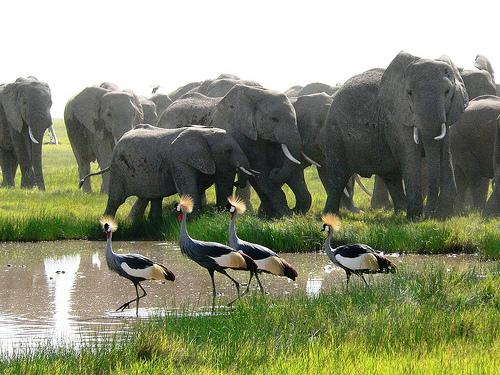What animals are interacting with each other in the image? Elephants and birds are interacting in the image, with birds walking in the water and elephants walking on the grass. Examine the image and determine whether any objects in the image could potentially cause harm or danger. There is no apparent threat or danger in the image, as it depicts a peaceful scene of elephants and birds in a natural environment. Using your understanding of the image's content, predict what might happen next. The elephants might continue to walk and graze on the grass, while the birds may keep walking in the water or take flight at some point, with their interactions remaining peaceful and undisturbed. Ensure the image's quality by describing the clarity and visibility of important elements. The image has good quality, with the objects clearly visible and well-defined, such as the elephants, birds, water, grass, and even finer details like elephant tusks and tails. Infer the possible reasons why elephants and birds are present in the same area. The elephants and birds might be present in the same area because they are both seeking water and food resources, or because they share a harmonious coexistence in their natural habitat. Describe the state of the water and its surroundings in the image. The water has ripples on the surface and a murky brown color, with a light reflection from the sun. It's surrounded by green grass, and the elephants and the birds are walking through or near the water. Analyze the sentiment of the image, and describe any emotions or feelings that the image may evoke. The image evokes a sense of tranquility and peacefulness, as it showcases a serene scene of elephants and birds interacting in a natural environment with water and grass. Count the number of elephants in the image and describe their positions. There are five elephants in the image: one large gray elephant looking forward, a baby elephant near its mother, a smallest elephant walking by water, a standing grey elephant, and another standing grey elephant with different positions. Identify the colors and size of the grass in the image. There is tall yellow and green grass that has a width of 207 and a height of 207. Determine the number of birds in the image, and briefly describe their appearances and actions. There are four birds in the image: a black and white lead bird, a black and white second bird, a black and white right hand bird, and a bird with one leg in water and one in the air. They all are walking in the water. Identify any birds that are standing on one leg. Bird with one leg in the water and one in the air, X:95 Y:206 Width:76 Height:76 Locate the white seagull perched on one of the elephants' backs. Mention how its feathers contrast with the elephant's gray skin. The image information does not include a seagull or any object implying it, so the instruction misleads the user by directing them to find an object that doesn't exist in the image. Describe the sentiment evoked by the image. The image evokes a sense of tranquility and harmony with nature. Search for a pink flamingo standing near the water's edge, and notice its majestic posture. No, it's not mentioned in the image. What is the main subject of the image? A group of elephants on the grass by a body of water. Describe the interaction between the baby elephant and its mother. The baby elephant is walking close to its mother, suggesting a bond between them. List three objects that are present in the image. Birds walking in the water, tall yellow and green grass, reflection from the sun on the water. Could you kindly identify the orange butterfly perched on the tall green grass? Comment on its vibrant color and pattern. The image information does not include any butterfly, so asking the user to find one would lead to confusion as they search for an object that isn't present. Determine the exact position of the stone in the grass by water. X:129, Y:337, Width:38, Height:38 Count the total number of birds walking in the water. Four What is the overall quality of the image? Good Is there any text visible in the image? No Which object is closest to the top-left corner of the image? Ripples on the water Please provide a description of the scene shown in the image. The image depicts a group of elephants walking on grass by a body of water, with birds wading in the water and tall grass surrounding the area. Locate the object described as "elephant tail". X:72, Y:156, Width:38, Height:38 Determine the attributes for the black and white lead bird. X:87, Y:203, Width:93, Height:93 Observe the group of people in the top left corner, having a picnic on the grass. Notice the variety of food and colorful blankets they've laid out. There is no mention of a group of people or a picnic scene in the image information. This instruction directs the user to focus on a nonexistent element, leading to confusion. Select the correct caption for the given image. A herd of walking elephants by a pond, with birds walking in the water and tall grass surrounding the area. Please find the baby hippopotamus swimming in the murky brown pond water. Describe its playful demeanor and the water droplets splashing around it. No baby hippopotamus is included in the provided image list, so this instruction guides the user to search for an object that doesn't exist in the image, leading to misunderstanding. Point out the object 'a tall feathered bird'. X:317, Y:211, Width:84, Height:84 How would you describe the position of the smallest elephant in relation to the water? The smallest elephant is walking by the water. What is the purpose of the long white elephant tusks? The tusks serve as a tool for protection, lifting objects, and foraging. Can you point out the tall palm tree casting its shadow on the sandy shore along the water's edge? Describe the patterns created by its leaves on the sand. There is no mention of a palm tree or a sandy shore in the given image information. This instruction would lead the user to search for something that is not in the image, causing confusion. Segment and label different regions of the image including grass, water, and elephants. Regions: Grass (different clusters), murky brown pond water, shoreline, body of water, group of elephants on grass, and baby elephant near mother Identify any anomalies or unusual aspects in the image. A bird with one leg in the water and one in the air. What are the characteristics of the water in the image? Murky and brown with ripples and light reflections from the sun. 